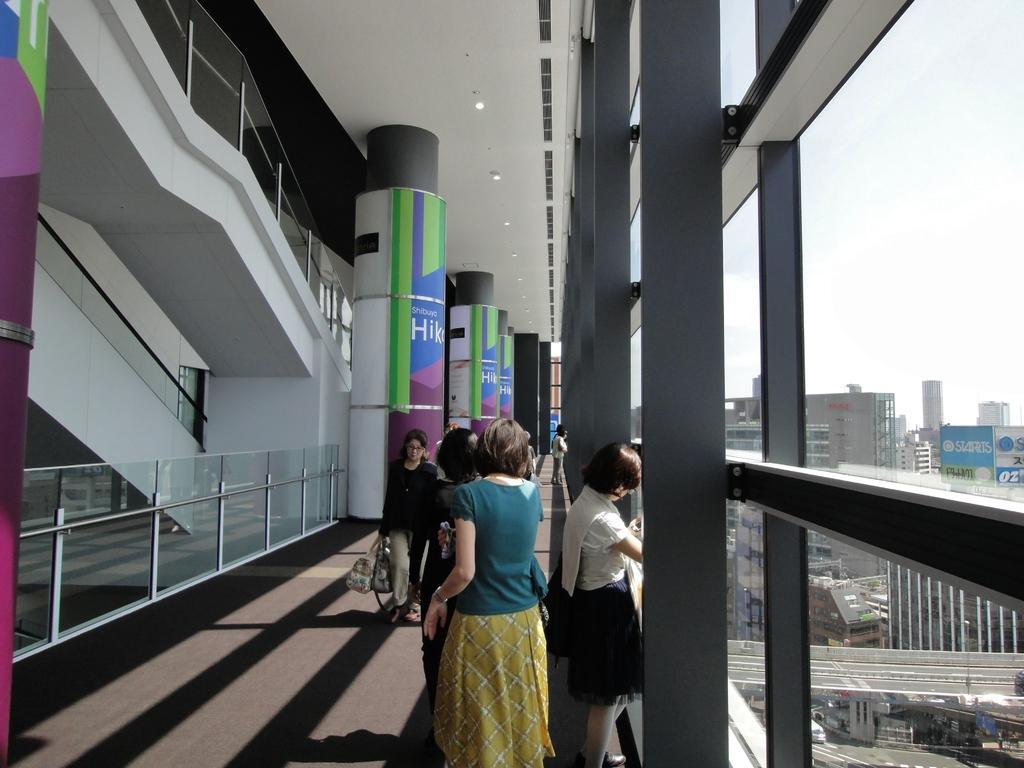Can you describe this image briefly? In this image I can see the floor, the glass railing, number of persons standing, few pillars, the ceiling, few lights and the glass windows through which I can see few buildings, few boards, few vehicles and the sky. 